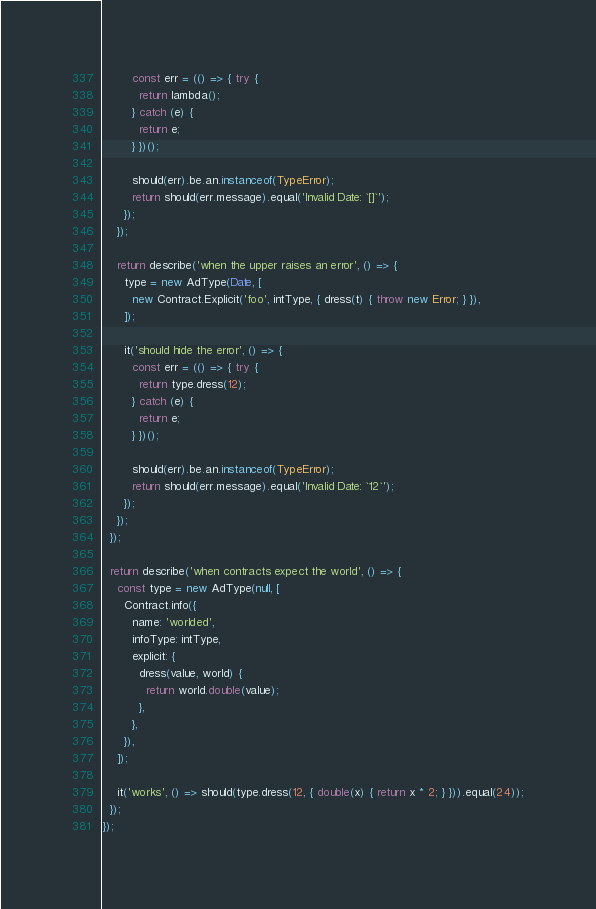<code> <loc_0><loc_0><loc_500><loc_500><_JavaScript_>        const err = (() => { try {
          return lambda();
        } catch (e) {
          return e;
        } })();

        should(err).be.an.instanceof(TypeError);
        return should(err.message).equal('Invalid Date: `[]`');
      });
    });

    return describe('when the upper raises an error', () => {
      type = new AdType(Date, [
        new Contract.Explicit('foo', intType, { dress(t) { throw new Error; } }),
      ]);

      it('should hide the error', () => {
        const err = (() => { try {
          return type.dress(12);
        } catch (e) {
          return e;
        } })();

        should(err).be.an.instanceof(TypeError);
        return should(err.message).equal('Invalid Date: `12`');
      });
    });
  });

  return describe('when contracts expect the world', () => {
    const type = new AdType(null, [
      Contract.info({
        name: 'worlded',
        infoType: intType,
        explicit: {
          dress(value, world) {
            return world.double(value);
          },
        },
      }),
    ]);

    it('works', () => should(type.dress(12, { double(x) { return x * 2; } })).equal(24));
  });
});
</code> 